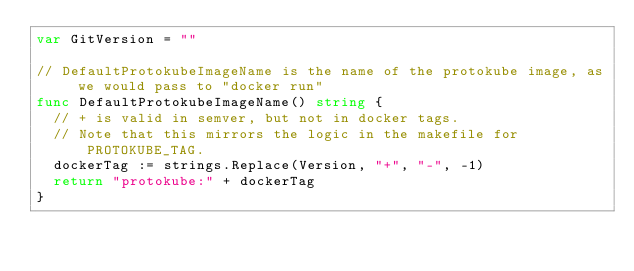Convert code to text. <code><loc_0><loc_0><loc_500><loc_500><_Go_>var GitVersion = ""

// DefaultProtokubeImageName is the name of the protokube image, as we would pass to "docker run"
func DefaultProtokubeImageName() string {
	// + is valid in semver, but not in docker tags.
	// Note that this mirrors the logic in the makefile for PROTOKUBE_TAG.
	dockerTag := strings.Replace(Version, "+", "-", -1)
	return "protokube:" + dockerTag
}
</code> 